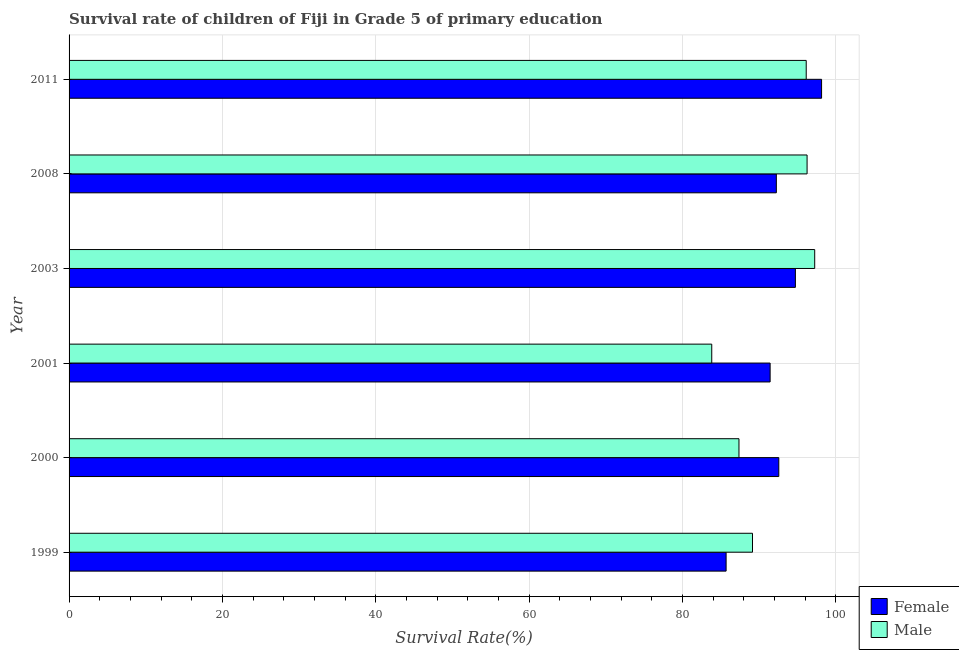How many different coloured bars are there?
Ensure brevity in your answer.  2. Are the number of bars per tick equal to the number of legend labels?
Keep it short and to the point. Yes. What is the label of the 6th group of bars from the top?
Offer a terse response. 1999. What is the survival rate of female students in primary education in 2000?
Ensure brevity in your answer.  92.54. Across all years, what is the maximum survival rate of male students in primary education?
Ensure brevity in your answer.  97.22. Across all years, what is the minimum survival rate of male students in primary education?
Your answer should be very brief. 83.8. In which year was the survival rate of female students in primary education minimum?
Offer a very short reply. 1999. What is the total survival rate of male students in primary education in the graph?
Give a very brief answer. 549.84. What is the difference between the survival rate of female students in primary education in 2000 and that in 2008?
Give a very brief answer. 0.32. What is the difference between the survival rate of male students in primary education in 2000 and the survival rate of female students in primary education in 2001?
Your answer should be very brief. -4.06. What is the average survival rate of female students in primary education per year?
Keep it short and to the point. 92.45. In the year 2000, what is the difference between the survival rate of male students in primary education and survival rate of female students in primary education?
Give a very brief answer. -5.19. In how many years, is the survival rate of male students in primary education greater than 4 %?
Your answer should be very brief. 6. What is the ratio of the survival rate of female students in primary education in 1999 to that in 2000?
Give a very brief answer. 0.93. Is the difference between the survival rate of female students in primary education in 2000 and 2008 greater than the difference between the survival rate of male students in primary education in 2000 and 2008?
Give a very brief answer. Yes. What is the difference between the highest and the second highest survival rate of female students in primary education?
Your answer should be compact. 3.41. What is the difference between the highest and the lowest survival rate of female students in primary education?
Make the answer very short. 12.45. In how many years, is the survival rate of female students in primary education greater than the average survival rate of female students in primary education taken over all years?
Provide a short and direct response. 3. How many bars are there?
Provide a succinct answer. 12. How many years are there in the graph?
Your answer should be very brief. 6. Does the graph contain any zero values?
Ensure brevity in your answer.  No. Does the graph contain grids?
Provide a succinct answer. Yes. Where does the legend appear in the graph?
Provide a succinct answer. Bottom right. What is the title of the graph?
Your answer should be very brief. Survival rate of children of Fiji in Grade 5 of primary education. Does "constant 2005 US$" appear as one of the legend labels in the graph?
Your answer should be compact. No. What is the label or title of the X-axis?
Your answer should be compact. Survival Rate(%). What is the Survival Rate(%) of Female in 1999?
Provide a short and direct response. 85.67. What is the Survival Rate(%) in Male in 1999?
Your answer should be compact. 89.11. What is the Survival Rate(%) in Female in 2000?
Provide a succinct answer. 92.54. What is the Survival Rate(%) of Male in 2000?
Your response must be concise. 87.35. What is the Survival Rate(%) in Female in 2001?
Your response must be concise. 91.41. What is the Survival Rate(%) in Male in 2001?
Offer a very short reply. 83.8. What is the Survival Rate(%) in Female in 2003?
Give a very brief answer. 94.71. What is the Survival Rate(%) in Male in 2003?
Provide a short and direct response. 97.22. What is the Survival Rate(%) of Female in 2008?
Your answer should be compact. 92.22. What is the Survival Rate(%) of Male in 2008?
Keep it short and to the point. 96.23. What is the Survival Rate(%) in Female in 2011?
Ensure brevity in your answer.  98.12. What is the Survival Rate(%) of Male in 2011?
Your answer should be compact. 96.12. Across all years, what is the maximum Survival Rate(%) of Female?
Make the answer very short. 98.12. Across all years, what is the maximum Survival Rate(%) of Male?
Provide a short and direct response. 97.22. Across all years, what is the minimum Survival Rate(%) of Female?
Offer a terse response. 85.67. Across all years, what is the minimum Survival Rate(%) of Male?
Make the answer very short. 83.8. What is the total Survival Rate(%) of Female in the graph?
Keep it short and to the point. 554.68. What is the total Survival Rate(%) of Male in the graph?
Provide a succinct answer. 549.84. What is the difference between the Survival Rate(%) in Female in 1999 and that in 2000?
Your answer should be compact. -6.87. What is the difference between the Survival Rate(%) of Male in 1999 and that in 2000?
Your response must be concise. 1.76. What is the difference between the Survival Rate(%) in Female in 1999 and that in 2001?
Keep it short and to the point. -5.74. What is the difference between the Survival Rate(%) in Male in 1999 and that in 2001?
Offer a very short reply. 5.31. What is the difference between the Survival Rate(%) of Female in 1999 and that in 2003?
Make the answer very short. -9.03. What is the difference between the Survival Rate(%) of Male in 1999 and that in 2003?
Offer a very short reply. -8.11. What is the difference between the Survival Rate(%) in Female in 1999 and that in 2008?
Ensure brevity in your answer.  -6.55. What is the difference between the Survival Rate(%) in Male in 1999 and that in 2008?
Provide a short and direct response. -7.12. What is the difference between the Survival Rate(%) of Female in 1999 and that in 2011?
Ensure brevity in your answer.  -12.45. What is the difference between the Survival Rate(%) in Male in 1999 and that in 2011?
Ensure brevity in your answer.  -7.01. What is the difference between the Survival Rate(%) of Female in 2000 and that in 2001?
Offer a very short reply. 1.13. What is the difference between the Survival Rate(%) of Male in 2000 and that in 2001?
Provide a succinct answer. 3.55. What is the difference between the Survival Rate(%) in Female in 2000 and that in 2003?
Offer a terse response. -2.16. What is the difference between the Survival Rate(%) of Male in 2000 and that in 2003?
Ensure brevity in your answer.  -9.87. What is the difference between the Survival Rate(%) of Female in 2000 and that in 2008?
Make the answer very short. 0.32. What is the difference between the Survival Rate(%) in Male in 2000 and that in 2008?
Ensure brevity in your answer.  -8.88. What is the difference between the Survival Rate(%) in Female in 2000 and that in 2011?
Provide a short and direct response. -5.58. What is the difference between the Survival Rate(%) in Male in 2000 and that in 2011?
Provide a short and direct response. -8.77. What is the difference between the Survival Rate(%) of Female in 2001 and that in 2003?
Offer a very short reply. -3.29. What is the difference between the Survival Rate(%) in Male in 2001 and that in 2003?
Your answer should be very brief. -13.42. What is the difference between the Survival Rate(%) of Female in 2001 and that in 2008?
Offer a terse response. -0.81. What is the difference between the Survival Rate(%) in Male in 2001 and that in 2008?
Your response must be concise. -12.43. What is the difference between the Survival Rate(%) in Female in 2001 and that in 2011?
Provide a short and direct response. -6.71. What is the difference between the Survival Rate(%) in Male in 2001 and that in 2011?
Offer a terse response. -12.32. What is the difference between the Survival Rate(%) of Female in 2003 and that in 2008?
Provide a short and direct response. 2.48. What is the difference between the Survival Rate(%) in Female in 2003 and that in 2011?
Keep it short and to the point. -3.41. What is the difference between the Survival Rate(%) of Male in 2003 and that in 2011?
Offer a terse response. 1.11. What is the difference between the Survival Rate(%) of Female in 2008 and that in 2011?
Keep it short and to the point. -5.9. What is the difference between the Survival Rate(%) in Male in 2008 and that in 2011?
Keep it short and to the point. 0.11. What is the difference between the Survival Rate(%) of Female in 1999 and the Survival Rate(%) of Male in 2000?
Ensure brevity in your answer.  -1.68. What is the difference between the Survival Rate(%) of Female in 1999 and the Survival Rate(%) of Male in 2001?
Offer a terse response. 1.87. What is the difference between the Survival Rate(%) in Female in 1999 and the Survival Rate(%) in Male in 2003?
Make the answer very short. -11.55. What is the difference between the Survival Rate(%) of Female in 1999 and the Survival Rate(%) of Male in 2008?
Your response must be concise. -10.56. What is the difference between the Survival Rate(%) of Female in 1999 and the Survival Rate(%) of Male in 2011?
Ensure brevity in your answer.  -10.45. What is the difference between the Survival Rate(%) in Female in 2000 and the Survival Rate(%) in Male in 2001?
Offer a very short reply. 8.74. What is the difference between the Survival Rate(%) in Female in 2000 and the Survival Rate(%) in Male in 2003?
Offer a very short reply. -4.68. What is the difference between the Survival Rate(%) in Female in 2000 and the Survival Rate(%) in Male in 2008?
Offer a very short reply. -3.69. What is the difference between the Survival Rate(%) of Female in 2000 and the Survival Rate(%) of Male in 2011?
Give a very brief answer. -3.58. What is the difference between the Survival Rate(%) of Female in 2001 and the Survival Rate(%) of Male in 2003?
Provide a short and direct response. -5.81. What is the difference between the Survival Rate(%) of Female in 2001 and the Survival Rate(%) of Male in 2008?
Give a very brief answer. -4.82. What is the difference between the Survival Rate(%) of Female in 2001 and the Survival Rate(%) of Male in 2011?
Offer a very short reply. -4.71. What is the difference between the Survival Rate(%) of Female in 2003 and the Survival Rate(%) of Male in 2008?
Make the answer very short. -1.53. What is the difference between the Survival Rate(%) in Female in 2003 and the Survival Rate(%) in Male in 2011?
Make the answer very short. -1.41. What is the difference between the Survival Rate(%) of Female in 2008 and the Survival Rate(%) of Male in 2011?
Offer a very short reply. -3.9. What is the average Survival Rate(%) of Female per year?
Provide a succinct answer. 92.45. What is the average Survival Rate(%) in Male per year?
Provide a succinct answer. 91.64. In the year 1999, what is the difference between the Survival Rate(%) of Female and Survival Rate(%) of Male?
Your answer should be very brief. -3.44. In the year 2000, what is the difference between the Survival Rate(%) of Female and Survival Rate(%) of Male?
Ensure brevity in your answer.  5.19. In the year 2001, what is the difference between the Survival Rate(%) of Female and Survival Rate(%) of Male?
Your answer should be very brief. 7.61. In the year 2003, what is the difference between the Survival Rate(%) of Female and Survival Rate(%) of Male?
Your answer should be very brief. -2.52. In the year 2008, what is the difference between the Survival Rate(%) in Female and Survival Rate(%) in Male?
Make the answer very short. -4.01. In the year 2011, what is the difference between the Survival Rate(%) in Female and Survival Rate(%) in Male?
Give a very brief answer. 2. What is the ratio of the Survival Rate(%) in Female in 1999 to that in 2000?
Your answer should be compact. 0.93. What is the ratio of the Survival Rate(%) in Male in 1999 to that in 2000?
Make the answer very short. 1.02. What is the ratio of the Survival Rate(%) in Female in 1999 to that in 2001?
Offer a terse response. 0.94. What is the ratio of the Survival Rate(%) of Male in 1999 to that in 2001?
Provide a short and direct response. 1.06. What is the ratio of the Survival Rate(%) of Female in 1999 to that in 2003?
Provide a short and direct response. 0.9. What is the ratio of the Survival Rate(%) in Male in 1999 to that in 2003?
Ensure brevity in your answer.  0.92. What is the ratio of the Survival Rate(%) of Female in 1999 to that in 2008?
Your answer should be very brief. 0.93. What is the ratio of the Survival Rate(%) of Male in 1999 to that in 2008?
Ensure brevity in your answer.  0.93. What is the ratio of the Survival Rate(%) of Female in 1999 to that in 2011?
Your response must be concise. 0.87. What is the ratio of the Survival Rate(%) of Male in 1999 to that in 2011?
Offer a very short reply. 0.93. What is the ratio of the Survival Rate(%) in Female in 2000 to that in 2001?
Give a very brief answer. 1.01. What is the ratio of the Survival Rate(%) in Male in 2000 to that in 2001?
Keep it short and to the point. 1.04. What is the ratio of the Survival Rate(%) of Female in 2000 to that in 2003?
Your response must be concise. 0.98. What is the ratio of the Survival Rate(%) in Male in 2000 to that in 2003?
Your response must be concise. 0.9. What is the ratio of the Survival Rate(%) in Female in 2000 to that in 2008?
Your answer should be very brief. 1. What is the ratio of the Survival Rate(%) of Male in 2000 to that in 2008?
Your answer should be very brief. 0.91. What is the ratio of the Survival Rate(%) of Female in 2000 to that in 2011?
Offer a very short reply. 0.94. What is the ratio of the Survival Rate(%) of Male in 2000 to that in 2011?
Keep it short and to the point. 0.91. What is the ratio of the Survival Rate(%) in Female in 2001 to that in 2003?
Offer a terse response. 0.97. What is the ratio of the Survival Rate(%) of Male in 2001 to that in 2003?
Ensure brevity in your answer.  0.86. What is the ratio of the Survival Rate(%) in Female in 2001 to that in 2008?
Your answer should be very brief. 0.99. What is the ratio of the Survival Rate(%) of Male in 2001 to that in 2008?
Your response must be concise. 0.87. What is the ratio of the Survival Rate(%) in Female in 2001 to that in 2011?
Your answer should be compact. 0.93. What is the ratio of the Survival Rate(%) in Male in 2001 to that in 2011?
Provide a succinct answer. 0.87. What is the ratio of the Survival Rate(%) of Female in 2003 to that in 2008?
Offer a very short reply. 1.03. What is the ratio of the Survival Rate(%) in Male in 2003 to that in 2008?
Your answer should be very brief. 1.01. What is the ratio of the Survival Rate(%) of Female in 2003 to that in 2011?
Your answer should be very brief. 0.97. What is the ratio of the Survival Rate(%) of Male in 2003 to that in 2011?
Make the answer very short. 1.01. What is the ratio of the Survival Rate(%) in Female in 2008 to that in 2011?
Offer a terse response. 0.94. What is the difference between the highest and the second highest Survival Rate(%) in Female?
Provide a succinct answer. 3.41. What is the difference between the highest and the lowest Survival Rate(%) in Female?
Ensure brevity in your answer.  12.45. What is the difference between the highest and the lowest Survival Rate(%) of Male?
Your answer should be very brief. 13.42. 